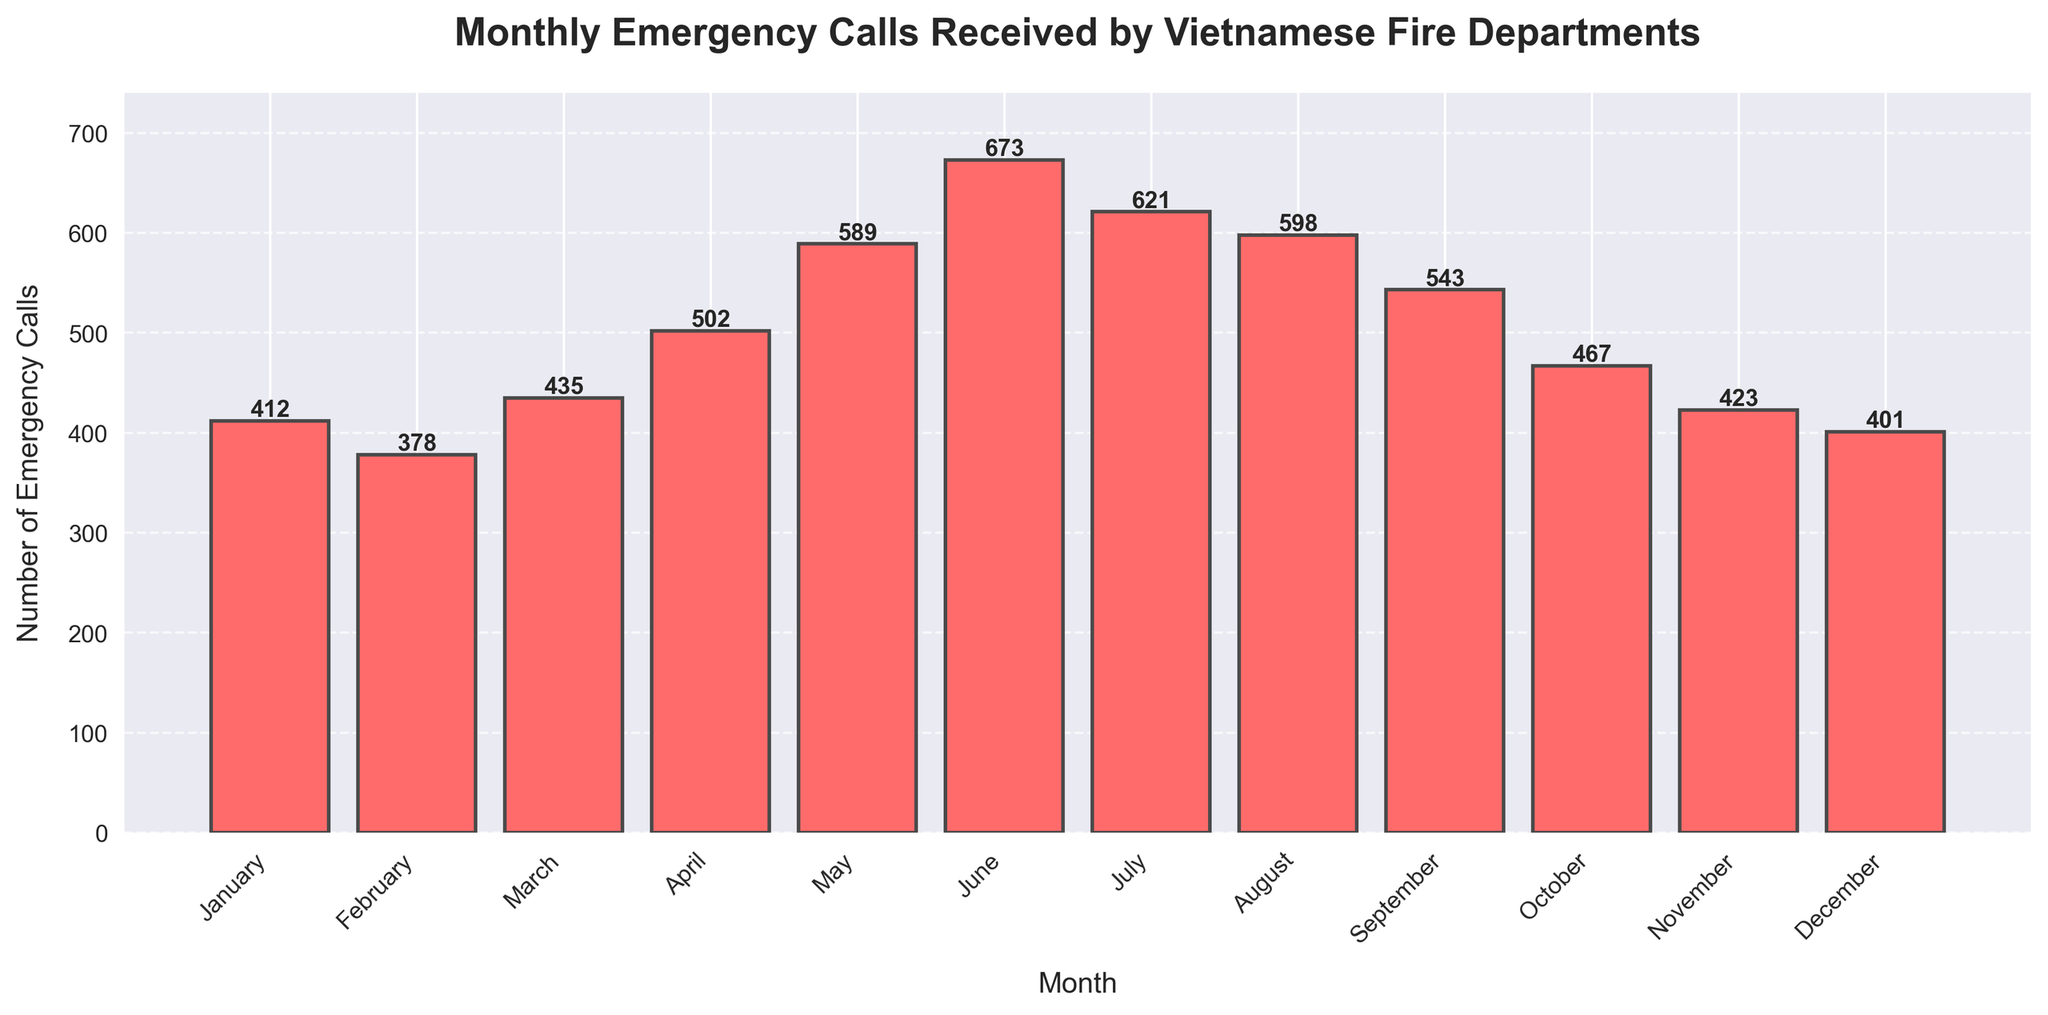How many emergency calls were received in May? Look for the bar labeled "May" and read the height value displayed on it. The text on the bar shows the number of calls.
Answer: 589 Which month had the highest number of emergency calls? Identify the tallest bar in the chart. The label on this bar indicates the month with the highest number of calls.
Answer: June Which month had more emergency calls: February or October? Compare the heights of the bars labeled "February" and "October." February has 378 calls, while October has 467 calls.
Answer: October What is the sum of emergency calls received in January and July? Find the bars labeled "January" and "July," and add their heights together. January has 412 calls and July has 621. The sum is 412 + 621 = 1033.
Answer: 1033 What's the difference in the number of calls between June and December? Look at the heights of the bars for "June" and "December." June has 673 calls and December has 401 calls. The difference is 673 - 401 = 272.
Answer: 272 How many more calls were received in March than in November? Read the heights of the bars for "March" and "November." March has 435 calls, and November has 423 calls. The difference is 435 - 423 = 12.
Answer: 12 What is the average number of emergency calls received from January to March? Sum the calls for January, February, and March, then divide by the number of months. (412 + 378 + 435) / 3 = 1225 / 3.
Answer: 408.33 What is the combined total of emergency calls in April, May, and June? Add the heights of the bars for April, May, and June. April has 502, May has 589, and June has 673 calls. The total is 502 + 589 + 673 = 1764.
Answer: 1764 Which quarter (i.e., three-month period) had the lowest number of emergency calls? Sum the calls month by month and compare the values for each quarter.
- Q1 (Jan-Mar): 412 + 378 + 435 = 1225
- Q2 (Apr-Jun): 502 + 589 + 673 = 1764
- Q3 (Jul-Sep): 621 + 598 + 543 = 1762
- Q4 (Oct-Dec): 467 + 423 + 401 = 1291
The lowest number of calls was received in Q1.
Answer: Q1 (Jan-Mar) What is the median number of emergency calls from all the months? Sort the numbers of calls to find the middle value. The sorted list is [378, 401, 412, 423, 435, 467, 502, 543, 589, 598, 621, 673]. The median is the average of the 6th and 7th values: (467 + 502) / 2 = 969 / 2 = 485
Answer: 485 